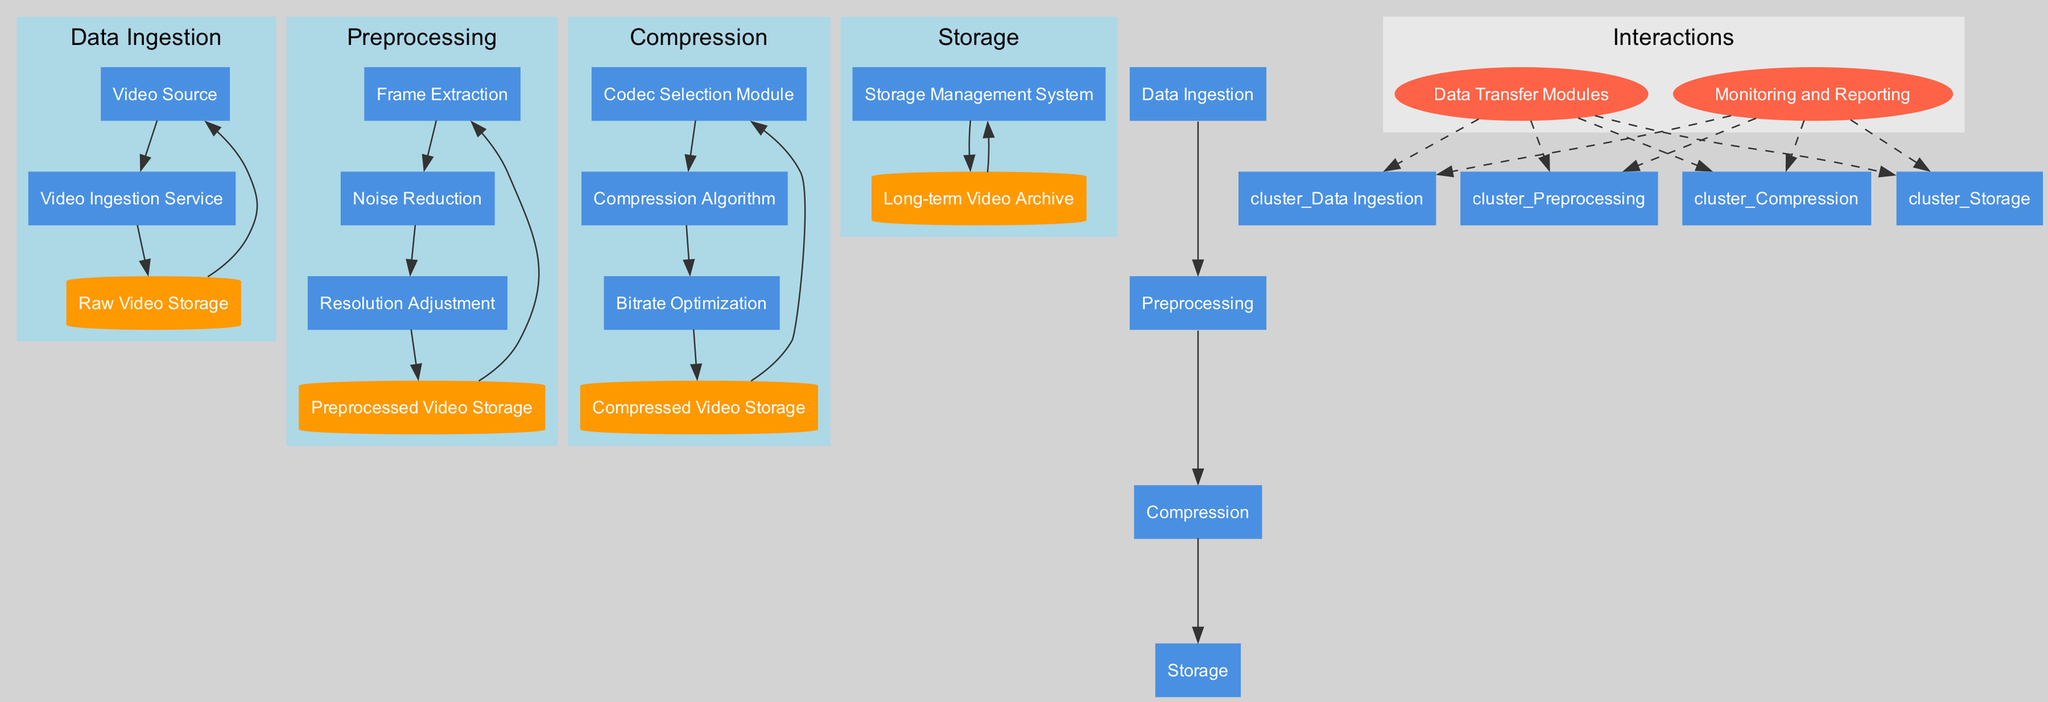What is the first phase in the video encoding workflow? The diagram starts with the "Data Ingestion" phase, which represents the initial step where video data is captured and transferred for further processing.
Answer: Data Ingestion How many components are in the Compression phase? In the Compression phase, there are three components: "Codec Selection Module," "Compression Algorithm," and "Bitrate Optimization." Therefore, the total count is three.
Answer: 3 What is the data store associated with Preprocessing? The data store related to the Preprocessing phase is named "Preprocessed Video Storage," which temporarily holds the processed video frames before further compression.
Answer: Preprocessed Video Storage Which component handles the optimization of the video bitrate during compression? The component responsible for this task in the Compression phase is "Bitrate Optimization," which ensures that the compressed video meets the desired bitrate requirements.
Answer: Bitrate Optimization How many interactions components are involved in data transfer monitoring? The diagram shows two interaction components: "Data Transfer Modules" and "Monitoring and Reporting." So, the total number of interaction components is two.
Answer: 2 What type of storage is used for archived compressed videos? The long-term storage for archived compressed videos in the diagram is referred to as "Long-term Video Archive." This indicates a specific storage designation for these files.
Answer: Long-term Video Archive Which phase includes noise reduction as part of its components? The noise reduction function is performed in the Preprocessing phase, where it helps clean up any unwanted noise from the video frames prior to compression.
Answer: Preprocessing What connects the Compression phase to the Storage phase in the workflow? The diagram indicates a direct edge connecting the last component of the Compression phase to the first component of the Storage phase, showing the flow of data between these two phases.
Answer: Edge Which data store is immediately after "Frame Extraction" in the Preprocessing phase? The data store that follows the "Frame Extraction" component in the Preprocessing phase is "Preprocessed Video Storage," which temporarily holds the extracted frames.
Answer: Preprocessed Video Storage 